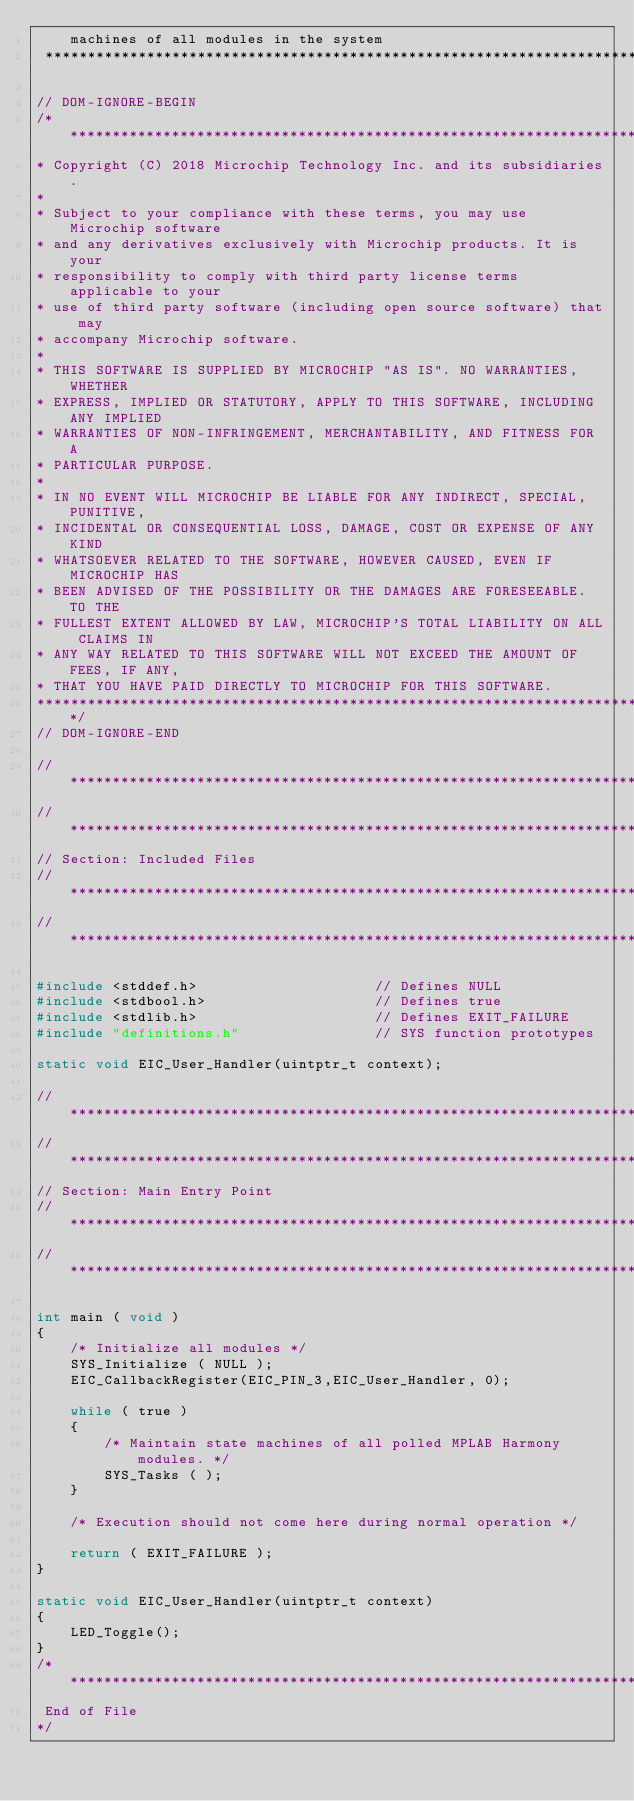<code> <loc_0><loc_0><loc_500><loc_500><_C_>    machines of all modules in the system
 *******************************************************************************/

// DOM-IGNORE-BEGIN
/*******************************************************************************
* Copyright (C) 2018 Microchip Technology Inc. and its subsidiaries.
*
* Subject to your compliance with these terms, you may use Microchip software
* and any derivatives exclusively with Microchip products. It is your
* responsibility to comply with third party license terms applicable to your
* use of third party software (including open source software) that may
* accompany Microchip software.
*
* THIS SOFTWARE IS SUPPLIED BY MICROCHIP "AS IS". NO WARRANTIES, WHETHER
* EXPRESS, IMPLIED OR STATUTORY, APPLY TO THIS SOFTWARE, INCLUDING ANY IMPLIED
* WARRANTIES OF NON-INFRINGEMENT, MERCHANTABILITY, AND FITNESS FOR A
* PARTICULAR PURPOSE.
*
* IN NO EVENT WILL MICROCHIP BE LIABLE FOR ANY INDIRECT, SPECIAL, PUNITIVE,
* INCIDENTAL OR CONSEQUENTIAL LOSS, DAMAGE, COST OR EXPENSE OF ANY KIND
* WHATSOEVER RELATED TO THE SOFTWARE, HOWEVER CAUSED, EVEN IF MICROCHIP HAS
* BEEN ADVISED OF THE POSSIBILITY OR THE DAMAGES ARE FORESEEABLE. TO THE
* FULLEST EXTENT ALLOWED BY LAW, MICROCHIP'S TOTAL LIABILITY ON ALL CLAIMS IN
* ANY WAY RELATED TO THIS SOFTWARE WILL NOT EXCEED THE AMOUNT OF FEES, IF ANY,
* THAT YOU HAVE PAID DIRECTLY TO MICROCHIP FOR THIS SOFTWARE.
*******************************************************************************/
// DOM-IGNORE-END

// *****************************************************************************
// *****************************************************************************
// Section: Included Files
// *****************************************************************************
// *****************************************************************************

#include <stddef.h>                     // Defines NULL
#include <stdbool.h>                    // Defines true
#include <stdlib.h>                     // Defines EXIT_FAILURE
#include "definitions.h"                // SYS function prototypes

static void EIC_User_Handler(uintptr_t context);

// *****************************************************************************
// *****************************************************************************
// Section: Main Entry Point
// *****************************************************************************
// *****************************************************************************

int main ( void )
{
    /* Initialize all modules */
    SYS_Initialize ( NULL );
    EIC_CallbackRegister(EIC_PIN_3,EIC_User_Handler, 0);

    while ( true )
    {
        /* Maintain state machines of all polled MPLAB Harmony modules. */
        SYS_Tasks ( );
    }

    /* Execution should not come here during normal operation */

    return ( EXIT_FAILURE );
}

static void EIC_User_Handler(uintptr_t context)
{
    LED_Toggle();
}
/*******************************************************************************
 End of File
*/

</code> 